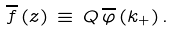<formula> <loc_0><loc_0><loc_500><loc_500>\overline { f } \left ( z \right ) \, \equiv \, Q \, \overline { \varphi } \left ( k _ { + } \right ) .</formula> 